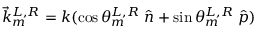<formula> <loc_0><loc_0><loc_500><loc_500>\vec { k } _ { m } ^ { L , R } = k ( \cos \theta _ { m } ^ { L , R } \, \hat { n } + \sin \theta _ { m } ^ { L , R } \, \hat { p } )</formula> 